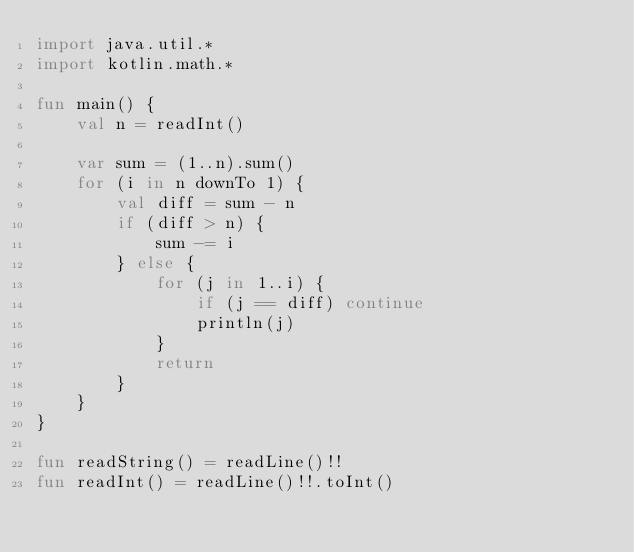Convert code to text. <code><loc_0><loc_0><loc_500><loc_500><_Kotlin_>import java.util.*
import kotlin.math.*

fun main() {
    val n = readInt()

    var sum = (1..n).sum()
    for (i in n downTo 1) {
        val diff = sum - n
        if (diff > n) {
            sum -= i
        } else {
            for (j in 1..i) {
                if (j == diff) continue
                println(j)
            }
            return
        }
    }
}

fun readString() = readLine()!!
fun readInt() = readLine()!!.toInt()</code> 